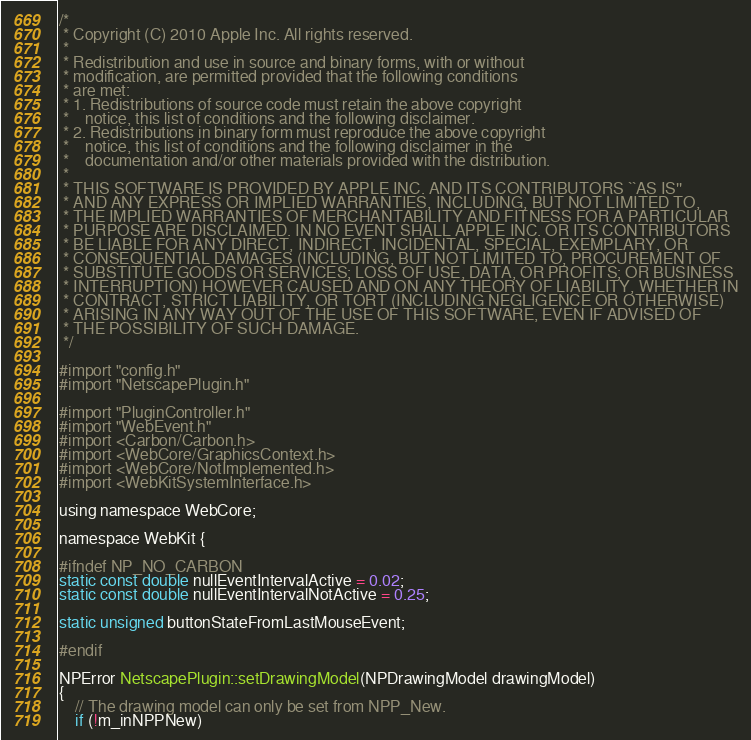Convert code to text. <code><loc_0><loc_0><loc_500><loc_500><_ObjectiveC_>/*
 * Copyright (C) 2010 Apple Inc. All rights reserved.
 *
 * Redistribution and use in source and binary forms, with or without
 * modification, are permitted provided that the following conditions
 * are met:
 * 1. Redistributions of source code must retain the above copyright
 *    notice, this list of conditions and the following disclaimer.
 * 2. Redistributions in binary form must reproduce the above copyright
 *    notice, this list of conditions and the following disclaimer in the
 *    documentation and/or other materials provided with the distribution.
 *
 * THIS SOFTWARE IS PROVIDED BY APPLE INC. AND ITS CONTRIBUTORS ``AS IS''
 * AND ANY EXPRESS OR IMPLIED WARRANTIES, INCLUDING, BUT NOT LIMITED TO,
 * THE IMPLIED WARRANTIES OF MERCHANTABILITY AND FITNESS FOR A PARTICULAR
 * PURPOSE ARE DISCLAIMED. IN NO EVENT SHALL APPLE INC. OR ITS CONTRIBUTORS
 * BE LIABLE FOR ANY DIRECT, INDIRECT, INCIDENTAL, SPECIAL, EXEMPLARY, OR
 * CONSEQUENTIAL DAMAGES (INCLUDING, BUT NOT LIMITED TO, PROCUREMENT OF
 * SUBSTITUTE GOODS OR SERVICES; LOSS OF USE, DATA, OR PROFITS; OR BUSINESS
 * INTERRUPTION) HOWEVER CAUSED AND ON ANY THEORY OF LIABILITY, WHETHER IN
 * CONTRACT, STRICT LIABILITY, OR TORT (INCLUDING NEGLIGENCE OR OTHERWISE)
 * ARISING IN ANY WAY OUT OF THE USE OF THIS SOFTWARE, EVEN IF ADVISED OF
 * THE POSSIBILITY OF SUCH DAMAGE.
 */

#import "config.h"
#import "NetscapePlugin.h"

#import "PluginController.h"
#import "WebEvent.h"
#import <Carbon/Carbon.h>
#import <WebCore/GraphicsContext.h>
#import <WebCore/NotImplemented.h>
#import <WebKitSystemInterface.h>

using namespace WebCore;

namespace WebKit {

#ifndef NP_NO_CARBON
static const double nullEventIntervalActive = 0.02;
static const double nullEventIntervalNotActive = 0.25;

static unsigned buttonStateFromLastMouseEvent;

#endif

NPError NetscapePlugin::setDrawingModel(NPDrawingModel drawingModel)
{
    // The drawing model can only be set from NPP_New.
    if (!m_inNPPNew)</code> 